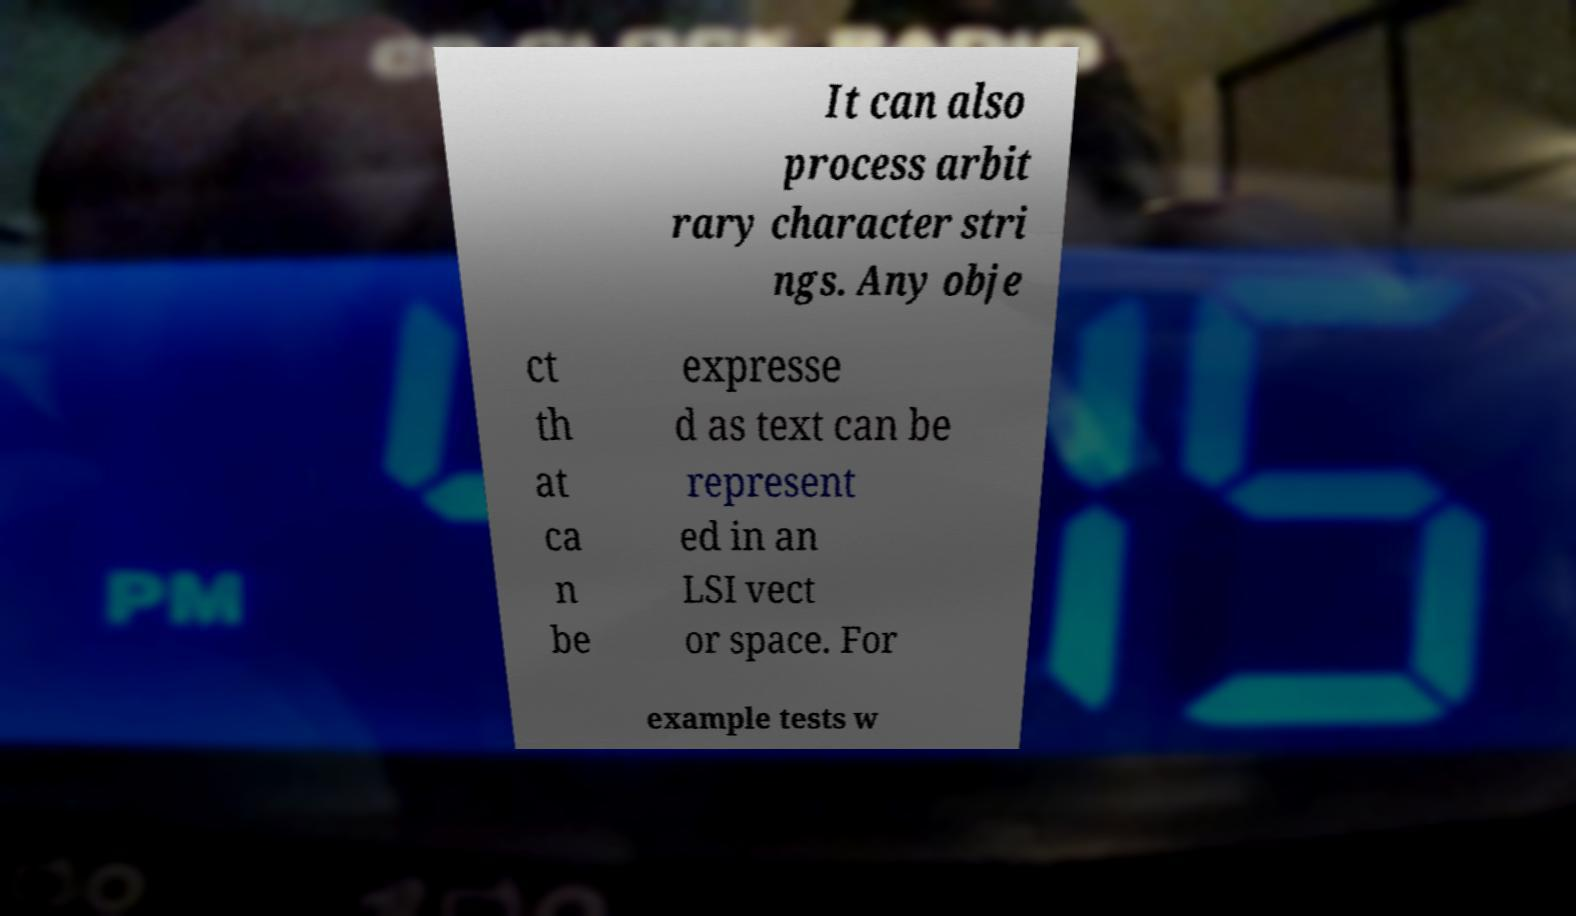Could you assist in decoding the text presented in this image and type it out clearly? It can also process arbit rary character stri ngs. Any obje ct th at ca n be expresse d as text can be represent ed in an LSI vect or space. For example tests w 